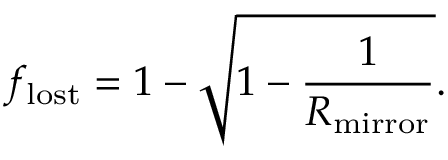<formula> <loc_0><loc_0><loc_500><loc_500>f _ { l o s t } = 1 - \sqrt { 1 - \frac { 1 } { R _ { m i r r o r } } } .</formula> 